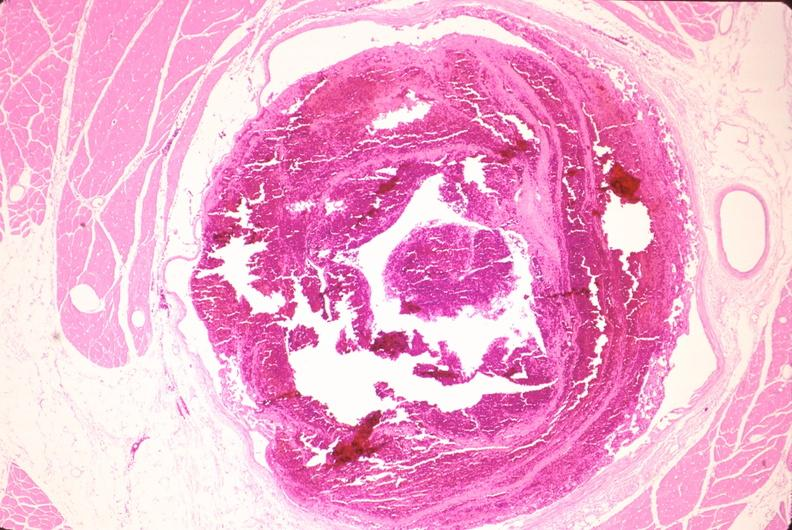s marfans syndrome present?
Answer the question using a single word or phrase. No 